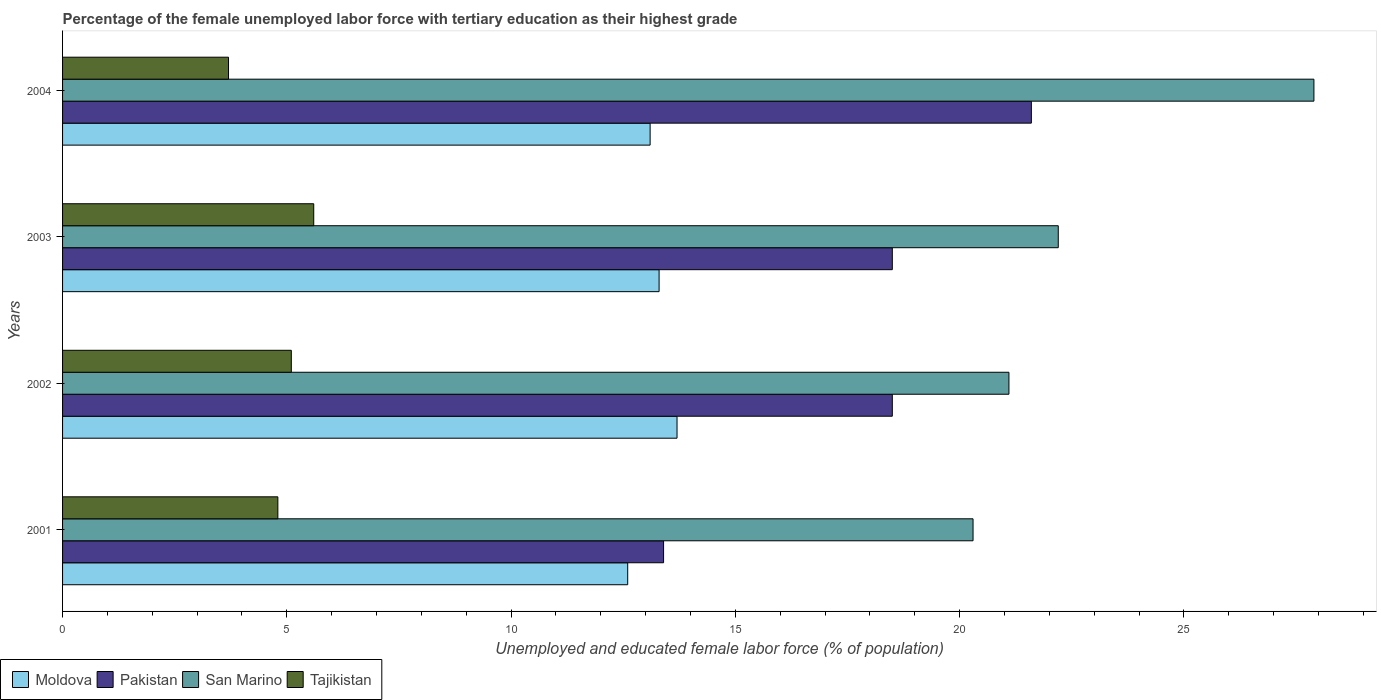How many different coloured bars are there?
Your answer should be compact. 4. Are the number of bars per tick equal to the number of legend labels?
Give a very brief answer. Yes. Are the number of bars on each tick of the Y-axis equal?
Provide a short and direct response. Yes. What is the label of the 1st group of bars from the top?
Make the answer very short. 2004. In how many cases, is the number of bars for a given year not equal to the number of legend labels?
Offer a very short reply. 0. What is the percentage of the unemployed female labor force with tertiary education in San Marino in 2002?
Offer a terse response. 21.1. Across all years, what is the maximum percentage of the unemployed female labor force with tertiary education in Pakistan?
Your answer should be compact. 21.6. Across all years, what is the minimum percentage of the unemployed female labor force with tertiary education in San Marino?
Make the answer very short. 20.3. In which year was the percentage of the unemployed female labor force with tertiary education in Moldova minimum?
Give a very brief answer. 2001. What is the total percentage of the unemployed female labor force with tertiary education in Moldova in the graph?
Make the answer very short. 52.7. What is the difference between the percentage of the unemployed female labor force with tertiary education in Pakistan in 2001 and that in 2002?
Your response must be concise. -5.1. What is the difference between the percentage of the unemployed female labor force with tertiary education in Pakistan in 2004 and the percentage of the unemployed female labor force with tertiary education in Moldova in 2003?
Give a very brief answer. 8.3. What is the average percentage of the unemployed female labor force with tertiary education in Moldova per year?
Provide a short and direct response. 13.18. In the year 2001, what is the difference between the percentage of the unemployed female labor force with tertiary education in San Marino and percentage of the unemployed female labor force with tertiary education in Tajikistan?
Your response must be concise. 15.5. In how many years, is the percentage of the unemployed female labor force with tertiary education in Tajikistan greater than 20 %?
Your answer should be compact. 0. What is the ratio of the percentage of the unemployed female labor force with tertiary education in Moldova in 2002 to that in 2003?
Ensure brevity in your answer.  1.03. Is the difference between the percentage of the unemployed female labor force with tertiary education in San Marino in 2001 and 2004 greater than the difference between the percentage of the unemployed female labor force with tertiary education in Tajikistan in 2001 and 2004?
Provide a succinct answer. No. What is the difference between the highest and the second highest percentage of the unemployed female labor force with tertiary education in Moldova?
Ensure brevity in your answer.  0.4. What is the difference between the highest and the lowest percentage of the unemployed female labor force with tertiary education in San Marino?
Ensure brevity in your answer.  7.6. Is it the case that in every year, the sum of the percentage of the unemployed female labor force with tertiary education in San Marino and percentage of the unemployed female labor force with tertiary education in Moldova is greater than the sum of percentage of the unemployed female labor force with tertiary education in Pakistan and percentage of the unemployed female labor force with tertiary education in Tajikistan?
Ensure brevity in your answer.  Yes. What does the 4th bar from the top in 2001 represents?
Provide a succinct answer. Moldova. What does the 4th bar from the bottom in 2001 represents?
Your answer should be compact. Tajikistan. Is it the case that in every year, the sum of the percentage of the unemployed female labor force with tertiary education in Moldova and percentage of the unemployed female labor force with tertiary education in Pakistan is greater than the percentage of the unemployed female labor force with tertiary education in Tajikistan?
Ensure brevity in your answer.  Yes. How many bars are there?
Ensure brevity in your answer.  16. Are all the bars in the graph horizontal?
Your answer should be very brief. Yes. What is the difference between two consecutive major ticks on the X-axis?
Ensure brevity in your answer.  5. Does the graph contain any zero values?
Your response must be concise. No. Does the graph contain grids?
Provide a succinct answer. No. Where does the legend appear in the graph?
Your answer should be very brief. Bottom left. How many legend labels are there?
Offer a terse response. 4. How are the legend labels stacked?
Ensure brevity in your answer.  Horizontal. What is the title of the graph?
Give a very brief answer. Percentage of the female unemployed labor force with tertiary education as their highest grade. What is the label or title of the X-axis?
Your response must be concise. Unemployed and educated female labor force (% of population). What is the Unemployed and educated female labor force (% of population) of Moldova in 2001?
Your answer should be very brief. 12.6. What is the Unemployed and educated female labor force (% of population) in Pakistan in 2001?
Provide a short and direct response. 13.4. What is the Unemployed and educated female labor force (% of population) of San Marino in 2001?
Keep it short and to the point. 20.3. What is the Unemployed and educated female labor force (% of population) in Tajikistan in 2001?
Offer a very short reply. 4.8. What is the Unemployed and educated female labor force (% of population) in Moldova in 2002?
Provide a short and direct response. 13.7. What is the Unemployed and educated female labor force (% of population) of San Marino in 2002?
Make the answer very short. 21.1. What is the Unemployed and educated female labor force (% of population) of Tajikistan in 2002?
Offer a terse response. 5.1. What is the Unemployed and educated female labor force (% of population) in Moldova in 2003?
Make the answer very short. 13.3. What is the Unemployed and educated female labor force (% of population) of Pakistan in 2003?
Your answer should be compact. 18.5. What is the Unemployed and educated female labor force (% of population) of San Marino in 2003?
Your answer should be compact. 22.2. What is the Unemployed and educated female labor force (% of population) in Tajikistan in 2003?
Your answer should be compact. 5.6. What is the Unemployed and educated female labor force (% of population) of Moldova in 2004?
Give a very brief answer. 13.1. What is the Unemployed and educated female labor force (% of population) in Pakistan in 2004?
Keep it short and to the point. 21.6. What is the Unemployed and educated female labor force (% of population) of San Marino in 2004?
Your answer should be compact. 27.9. What is the Unemployed and educated female labor force (% of population) of Tajikistan in 2004?
Give a very brief answer. 3.7. Across all years, what is the maximum Unemployed and educated female labor force (% of population) in Moldova?
Your response must be concise. 13.7. Across all years, what is the maximum Unemployed and educated female labor force (% of population) of Pakistan?
Your response must be concise. 21.6. Across all years, what is the maximum Unemployed and educated female labor force (% of population) in San Marino?
Your response must be concise. 27.9. Across all years, what is the maximum Unemployed and educated female labor force (% of population) in Tajikistan?
Your response must be concise. 5.6. Across all years, what is the minimum Unemployed and educated female labor force (% of population) in Moldova?
Provide a succinct answer. 12.6. Across all years, what is the minimum Unemployed and educated female labor force (% of population) in Pakistan?
Make the answer very short. 13.4. Across all years, what is the minimum Unemployed and educated female labor force (% of population) of San Marino?
Offer a very short reply. 20.3. Across all years, what is the minimum Unemployed and educated female labor force (% of population) in Tajikistan?
Your answer should be very brief. 3.7. What is the total Unemployed and educated female labor force (% of population) in Moldova in the graph?
Keep it short and to the point. 52.7. What is the total Unemployed and educated female labor force (% of population) of Pakistan in the graph?
Make the answer very short. 72. What is the total Unemployed and educated female labor force (% of population) in San Marino in the graph?
Your answer should be compact. 91.5. What is the total Unemployed and educated female labor force (% of population) in Tajikistan in the graph?
Your response must be concise. 19.2. What is the difference between the Unemployed and educated female labor force (% of population) of Pakistan in 2001 and that in 2002?
Keep it short and to the point. -5.1. What is the difference between the Unemployed and educated female labor force (% of population) of San Marino in 2001 and that in 2002?
Your answer should be compact. -0.8. What is the difference between the Unemployed and educated female labor force (% of population) of Moldova in 2001 and that in 2003?
Your answer should be compact. -0.7. What is the difference between the Unemployed and educated female labor force (% of population) in Pakistan in 2001 and that in 2003?
Ensure brevity in your answer.  -5.1. What is the difference between the Unemployed and educated female labor force (% of population) in Tajikistan in 2001 and that in 2003?
Ensure brevity in your answer.  -0.8. What is the difference between the Unemployed and educated female labor force (% of population) in Moldova in 2001 and that in 2004?
Provide a short and direct response. -0.5. What is the difference between the Unemployed and educated female labor force (% of population) in Pakistan in 2001 and that in 2004?
Your response must be concise. -8.2. What is the difference between the Unemployed and educated female labor force (% of population) of Moldova in 2002 and that in 2003?
Your response must be concise. 0.4. What is the difference between the Unemployed and educated female labor force (% of population) of San Marino in 2002 and that in 2003?
Give a very brief answer. -1.1. What is the difference between the Unemployed and educated female labor force (% of population) in Moldova in 2002 and that in 2004?
Your answer should be compact. 0.6. What is the difference between the Unemployed and educated female labor force (% of population) in Pakistan in 2002 and that in 2004?
Your answer should be very brief. -3.1. What is the difference between the Unemployed and educated female labor force (% of population) of San Marino in 2002 and that in 2004?
Keep it short and to the point. -6.8. What is the difference between the Unemployed and educated female labor force (% of population) of Tajikistan in 2002 and that in 2004?
Ensure brevity in your answer.  1.4. What is the difference between the Unemployed and educated female labor force (% of population) of Pakistan in 2003 and that in 2004?
Provide a succinct answer. -3.1. What is the difference between the Unemployed and educated female labor force (% of population) of Moldova in 2001 and the Unemployed and educated female labor force (% of population) of San Marino in 2002?
Provide a short and direct response. -8.5. What is the difference between the Unemployed and educated female labor force (% of population) in Pakistan in 2001 and the Unemployed and educated female labor force (% of population) in Tajikistan in 2002?
Your answer should be compact. 8.3. What is the difference between the Unemployed and educated female labor force (% of population) in San Marino in 2001 and the Unemployed and educated female labor force (% of population) in Tajikistan in 2002?
Provide a succinct answer. 15.2. What is the difference between the Unemployed and educated female labor force (% of population) of Moldova in 2001 and the Unemployed and educated female labor force (% of population) of Pakistan in 2003?
Keep it short and to the point. -5.9. What is the difference between the Unemployed and educated female labor force (% of population) of Moldova in 2001 and the Unemployed and educated female labor force (% of population) of Tajikistan in 2003?
Provide a short and direct response. 7. What is the difference between the Unemployed and educated female labor force (% of population) of Pakistan in 2001 and the Unemployed and educated female labor force (% of population) of San Marino in 2003?
Your answer should be compact. -8.8. What is the difference between the Unemployed and educated female labor force (% of population) in Pakistan in 2001 and the Unemployed and educated female labor force (% of population) in Tajikistan in 2003?
Make the answer very short. 7.8. What is the difference between the Unemployed and educated female labor force (% of population) in Moldova in 2001 and the Unemployed and educated female labor force (% of population) in Pakistan in 2004?
Keep it short and to the point. -9. What is the difference between the Unemployed and educated female labor force (% of population) in Moldova in 2001 and the Unemployed and educated female labor force (% of population) in San Marino in 2004?
Your answer should be very brief. -15.3. What is the difference between the Unemployed and educated female labor force (% of population) of Moldova in 2001 and the Unemployed and educated female labor force (% of population) of Tajikistan in 2004?
Your answer should be very brief. 8.9. What is the difference between the Unemployed and educated female labor force (% of population) in Pakistan in 2001 and the Unemployed and educated female labor force (% of population) in San Marino in 2004?
Provide a short and direct response. -14.5. What is the difference between the Unemployed and educated female labor force (% of population) of Pakistan in 2001 and the Unemployed and educated female labor force (% of population) of Tajikistan in 2004?
Ensure brevity in your answer.  9.7. What is the difference between the Unemployed and educated female labor force (% of population) in San Marino in 2001 and the Unemployed and educated female labor force (% of population) in Tajikistan in 2004?
Make the answer very short. 16.6. What is the difference between the Unemployed and educated female labor force (% of population) in Moldova in 2002 and the Unemployed and educated female labor force (% of population) in Tajikistan in 2003?
Offer a terse response. 8.1. What is the difference between the Unemployed and educated female labor force (% of population) of Pakistan in 2002 and the Unemployed and educated female labor force (% of population) of San Marino in 2003?
Offer a very short reply. -3.7. What is the difference between the Unemployed and educated female labor force (% of population) of San Marino in 2002 and the Unemployed and educated female labor force (% of population) of Tajikistan in 2003?
Offer a very short reply. 15.5. What is the difference between the Unemployed and educated female labor force (% of population) of Moldova in 2002 and the Unemployed and educated female labor force (% of population) of Pakistan in 2004?
Give a very brief answer. -7.9. What is the difference between the Unemployed and educated female labor force (% of population) in Pakistan in 2002 and the Unemployed and educated female labor force (% of population) in Tajikistan in 2004?
Your response must be concise. 14.8. What is the difference between the Unemployed and educated female labor force (% of population) in San Marino in 2002 and the Unemployed and educated female labor force (% of population) in Tajikistan in 2004?
Keep it short and to the point. 17.4. What is the difference between the Unemployed and educated female labor force (% of population) in Moldova in 2003 and the Unemployed and educated female labor force (% of population) in Pakistan in 2004?
Keep it short and to the point. -8.3. What is the difference between the Unemployed and educated female labor force (% of population) of Moldova in 2003 and the Unemployed and educated female labor force (% of population) of San Marino in 2004?
Your answer should be very brief. -14.6. What is the difference between the Unemployed and educated female labor force (% of population) of Pakistan in 2003 and the Unemployed and educated female labor force (% of population) of Tajikistan in 2004?
Your response must be concise. 14.8. What is the average Unemployed and educated female labor force (% of population) in Moldova per year?
Provide a succinct answer. 13.18. What is the average Unemployed and educated female labor force (% of population) of San Marino per year?
Offer a very short reply. 22.88. In the year 2001, what is the difference between the Unemployed and educated female labor force (% of population) in Moldova and Unemployed and educated female labor force (% of population) in Pakistan?
Make the answer very short. -0.8. In the year 2001, what is the difference between the Unemployed and educated female labor force (% of population) in Moldova and Unemployed and educated female labor force (% of population) in San Marino?
Make the answer very short. -7.7. In the year 2001, what is the difference between the Unemployed and educated female labor force (% of population) in Moldova and Unemployed and educated female labor force (% of population) in Tajikistan?
Ensure brevity in your answer.  7.8. In the year 2001, what is the difference between the Unemployed and educated female labor force (% of population) of Pakistan and Unemployed and educated female labor force (% of population) of San Marino?
Make the answer very short. -6.9. In the year 2002, what is the difference between the Unemployed and educated female labor force (% of population) of Moldova and Unemployed and educated female labor force (% of population) of San Marino?
Provide a short and direct response. -7.4. In the year 2002, what is the difference between the Unemployed and educated female labor force (% of population) in Moldova and Unemployed and educated female labor force (% of population) in Tajikistan?
Give a very brief answer. 8.6. In the year 2002, what is the difference between the Unemployed and educated female labor force (% of population) in Pakistan and Unemployed and educated female labor force (% of population) in San Marino?
Your answer should be very brief. -2.6. In the year 2002, what is the difference between the Unemployed and educated female labor force (% of population) of San Marino and Unemployed and educated female labor force (% of population) of Tajikistan?
Ensure brevity in your answer.  16. In the year 2003, what is the difference between the Unemployed and educated female labor force (% of population) of Moldova and Unemployed and educated female labor force (% of population) of Pakistan?
Make the answer very short. -5.2. In the year 2003, what is the difference between the Unemployed and educated female labor force (% of population) of Moldova and Unemployed and educated female labor force (% of population) of San Marino?
Give a very brief answer. -8.9. In the year 2003, what is the difference between the Unemployed and educated female labor force (% of population) of Moldova and Unemployed and educated female labor force (% of population) of Tajikistan?
Offer a very short reply. 7.7. In the year 2003, what is the difference between the Unemployed and educated female labor force (% of population) of Pakistan and Unemployed and educated female labor force (% of population) of San Marino?
Keep it short and to the point. -3.7. In the year 2003, what is the difference between the Unemployed and educated female labor force (% of population) of San Marino and Unemployed and educated female labor force (% of population) of Tajikistan?
Keep it short and to the point. 16.6. In the year 2004, what is the difference between the Unemployed and educated female labor force (% of population) of Moldova and Unemployed and educated female labor force (% of population) of San Marino?
Offer a very short reply. -14.8. In the year 2004, what is the difference between the Unemployed and educated female labor force (% of population) in Moldova and Unemployed and educated female labor force (% of population) in Tajikistan?
Your answer should be compact. 9.4. In the year 2004, what is the difference between the Unemployed and educated female labor force (% of population) in Pakistan and Unemployed and educated female labor force (% of population) in San Marino?
Your response must be concise. -6.3. In the year 2004, what is the difference between the Unemployed and educated female labor force (% of population) in Pakistan and Unemployed and educated female labor force (% of population) in Tajikistan?
Offer a very short reply. 17.9. In the year 2004, what is the difference between the Unemployed and educated female labor force (% of population) of San Marino and Unemployed and educated female labor force (% of population) of Tajikistan?
Your response must be concise. 24.2. What is the ratio of the Unemployed and educated female labor force (% of population) in Moldova in 2001 to that in 2002?
Give a very brief answer. 0.92. What is the ratio of the Unemployed and educated female labor force (% of population) of Pakistan in 2001 to that in 2002?
Your response must be concise. 0.72. What is the ratio of the Unemployed and educated female labor force (% of population) of San Marino in 2001 to that in 2002?
Your answer should be compact. 0.96. What is the ratio of the Unemployed and educated female labor force (% of population) of Moldova in 2001 to that in 2003?
Give a very brief answer. 0.95. What is the ratio of the Unemployed and educated female labor force (% of population) in Pakistan in 2001 to that in 2003?
Make the answer very short. 0.72. What is the ratio of the Unemployed and educated female labor force (% of population) in San Marino in 2001 to that in 2003?
Provide a succinct answer. 0.91. What is the ratio of the Unemployed and educated female labor force (% of population) in Tajikistan in 2001 to that in 2003?
Your response must be concise. 0.86. What is the ratio of the Unemployed and educated female labor force (% of population) of Moldova in 2001 to that in 2004?
Provide a succinct answer. 0.96. What is the ratio of the Unemployed and educated female labor force (% of population) in Pakistan in 2001 to that in 2004?
Provide a succinct answer. 0.62. What is the ratio of the Unemployed and educated female labor force (% of population) of San Marino in 2001 to that in 2004?
Provide a succinct answer. 0.73. What is the ratio of the Unemployed and educated female labor force (% of population) in Tajikistan in 2001 to that in 2004?
Your response must be concise. 1.3. What is the ratio of the Unemployed and educated female labor force (% of population) of Moldova in 2002 to that in 2003?
Keep it short and to the point. 1.03. What is the ratio of the Unemployed and educated female labor force (% of population) of Pakistan in 2002 to that in 2003?
Provide a succinct answer. 1. What is the ratio of the Unemployed and educated female labor force (% of population) in San Marino in 2002 to that in 2003?
Keep it short and to the point. 0.95. What is the ratio of the Unemployed and educated female labor force (% of population) in Tajikistan in 2002 to that in 2003?
Your answer should be very brief. 0.91. What is the ratio of the Unemployed and educated female labor force (% of population) in Moldova in 2002 to that in 2004?
Ensure brevity in your answer.  1.05. What is the ratio of the Unemployed and educated female labor force (% of population) of Pakistan in 2002 to that in 2004?
Ensure brevity in your answer.  0.86. What is the ratio of the Unemployed and educated female labor force (% of population) in San Marino in 2002 to that in 2004?
Ensure brevity in your answer.  0.76. What is the ratio of the Unemployed and educated female labor force (% of population) of Tajikistan in 2002 to that in 2004?
Offer a terse response. 1.38. What is the ratio of the Unemployed and educated female labor force (% of population) of Moldova in 2003 to that in 2004?
Offer a very short reply. 1.02. What is the ratio of the Unemployed and educated female labor force (% of population) of Pakistan in 2003 to that in 2004?
Ensure brevity in your answer.  0.86. What is the ratio of the Unemployed and educated female labor force (% of population) in San Marino in 2003 to that in 2004?
Give a very brief answer. 0.8. What is the ratio of the Unemployed and educated female labor force (% of population) of Tajikistan in 2003 to that in 2004?
Give a very brief answer. 1.51. What is the difference between the highest and the second highest Unemployed and educated female labor force (% of population) of Moldova?
Your answer should be very brief. 0.4. What is the difference between the highest and the second highest Unemployed and educated female labor force (% of population) in San Marino?
Your answer should be very brief. 5.7. What is the difference between the highest and the lowest Unemployed and educated female labor force (% of population) in Moldova?
Ensure brevity in your answer.  1.1. What is the difference between the highest and the lowest Unemployed and educated female labor force (% of population) of Pakistan?
Your response must be concise. 8.2. 